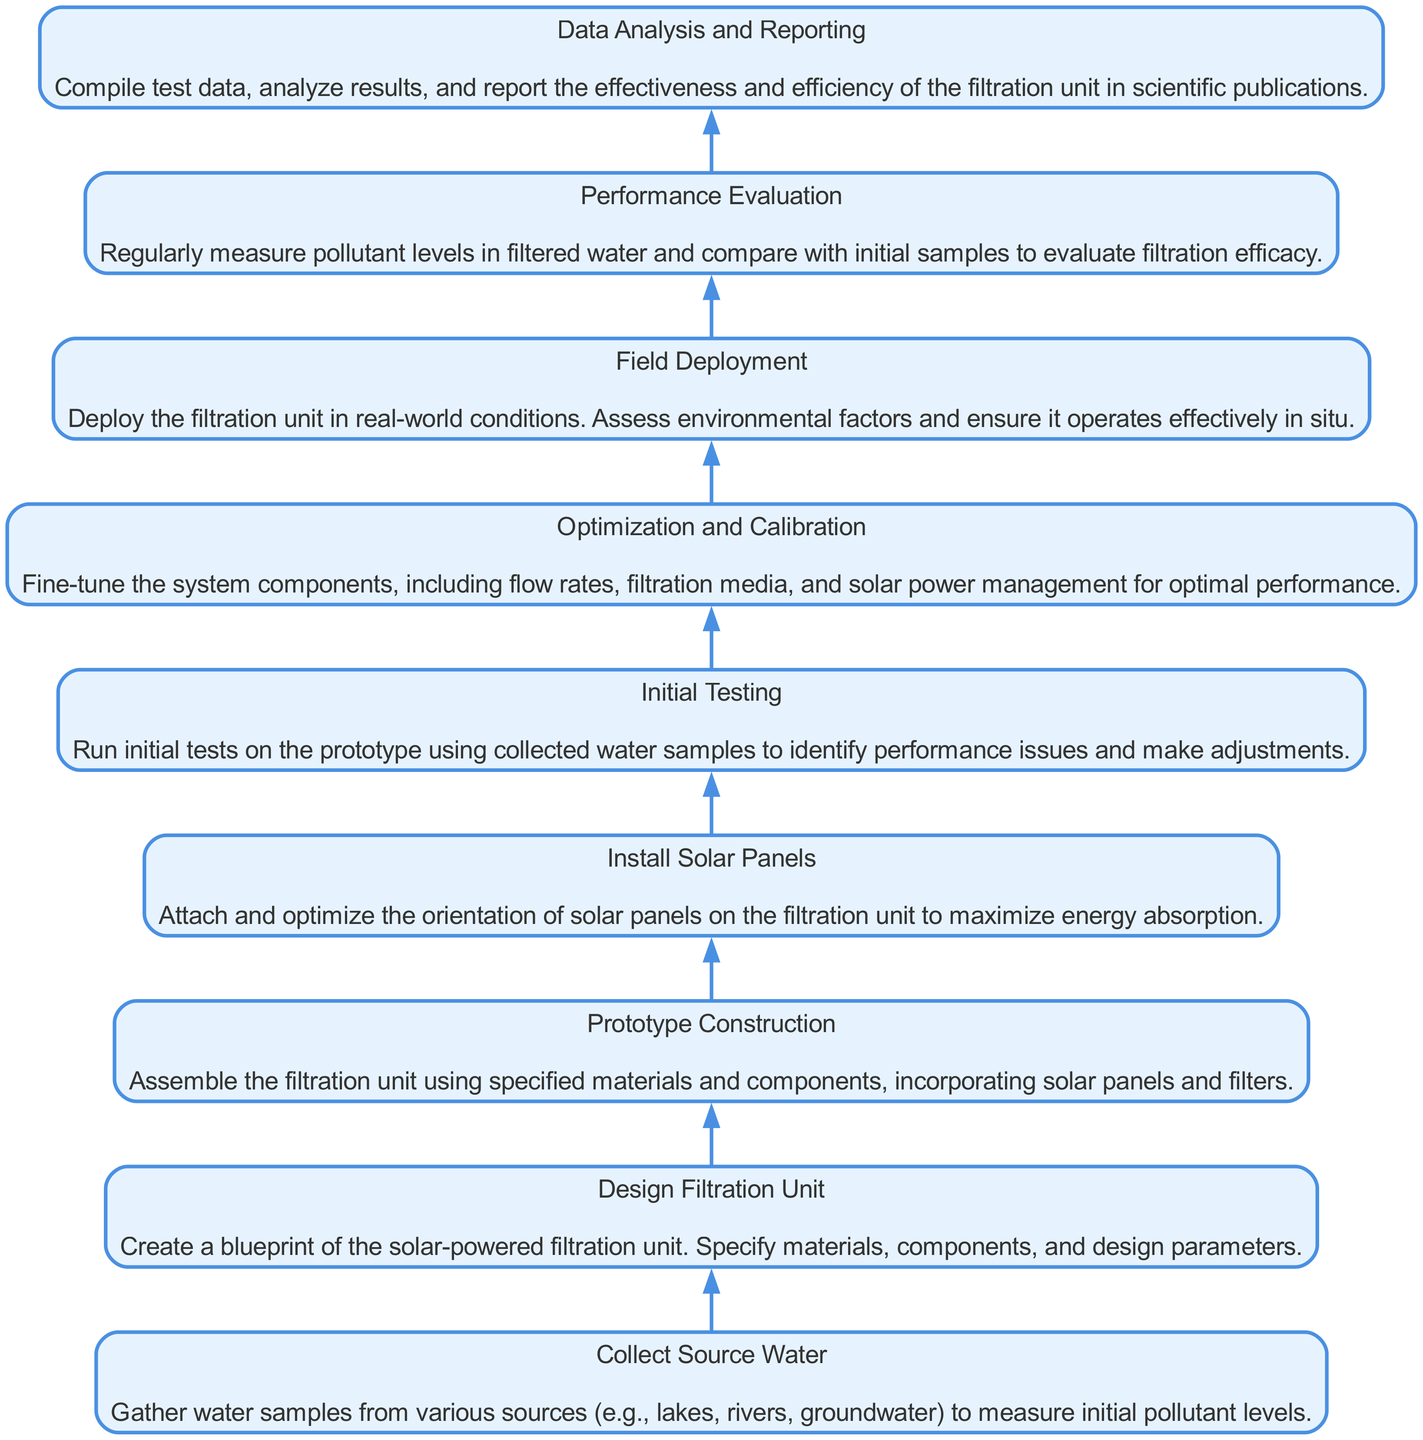What is the first step in the process? The diagram shows that the first step is "Collect Source Water," which indicates the starting point of the filtration unit's design and testing.
Answer: Collect Source Water How many nodes are in the diagram? The diagram lists eight distinct steps in the process, each represented as a node.
Answer: 8 What follows "Initial Testing"? After "Initial Testing," the next step in the process is "Optimization and Calibration," which indicates further refinement of the system.
Answer: Optimization and Calibration What is the last step in the process? The final step listed in the diagram is "Data Analysis and Reporting," indicating the completion of the project.
Answer: Data Analysis and Reporting Which step involves deploying the unit? "Field Deployment" is the step that includes taking the filtration unit into real-world conditions.
Answer: Field Deployment Which steps are directly related to solar panels? The steps related to solar panels are "Install Solar Panels," which specifies the attachment and orientation of the panels, and "Prototype Construction," which mentions incorporating solar panels into the unit.
Answer: Install Solar Panels, Prototype Construction What is the relationship between "Design Filtration Unit" and "Prototype Construction"? "Prototype Construction" is dependent on the "Design Filtration Unit," as the prototype is built based on the designs created in the previous step.
Answer: Prototype Construction depends on Design Filtration Unit What does the "Initial Testing" step evaluate? The "Initial Testing" step evaluates the performance of the prototype using collected water samples, which assists in identifying any issues with the design.
Answer: Performance issues How does "Optimization and Calibration" relate to "Performance Evaluation"? "Optimization and Calibration" occurs before "Performance Evaluation"; it adjusts the filtration system to ensure it is performing optimally prior to measuring its effectiveness in the subsequent evaluation step.
Answer: Optimization and Calibration precedes Performance Evaluation 